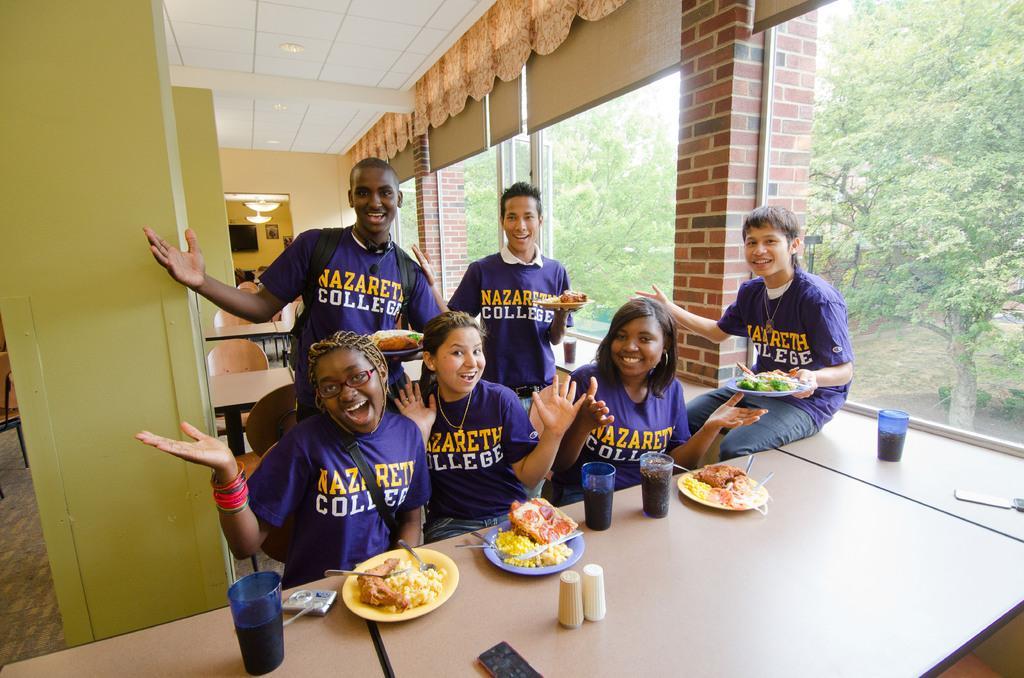Can you describe this image briefly? In this picture there are three women who are sitting on the chair. There are two men who are standing and holding a plate. There is a man sitting on the table and holding a plate. There is a glass on the table. There are trees at the background. 